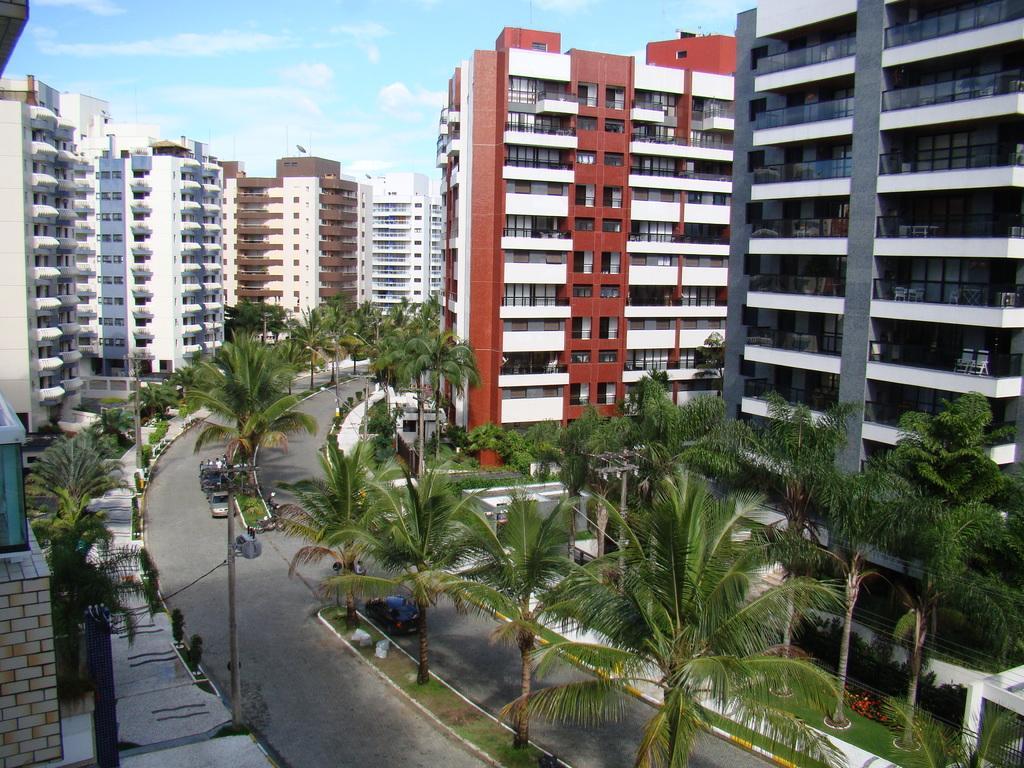Can you describe this image briefly? This is an outside image in this image we could see some buildings trees, at the bottom there is a road. On the road there are some vehicles and also there is grass and footpath, on the top of the image there is sky. 